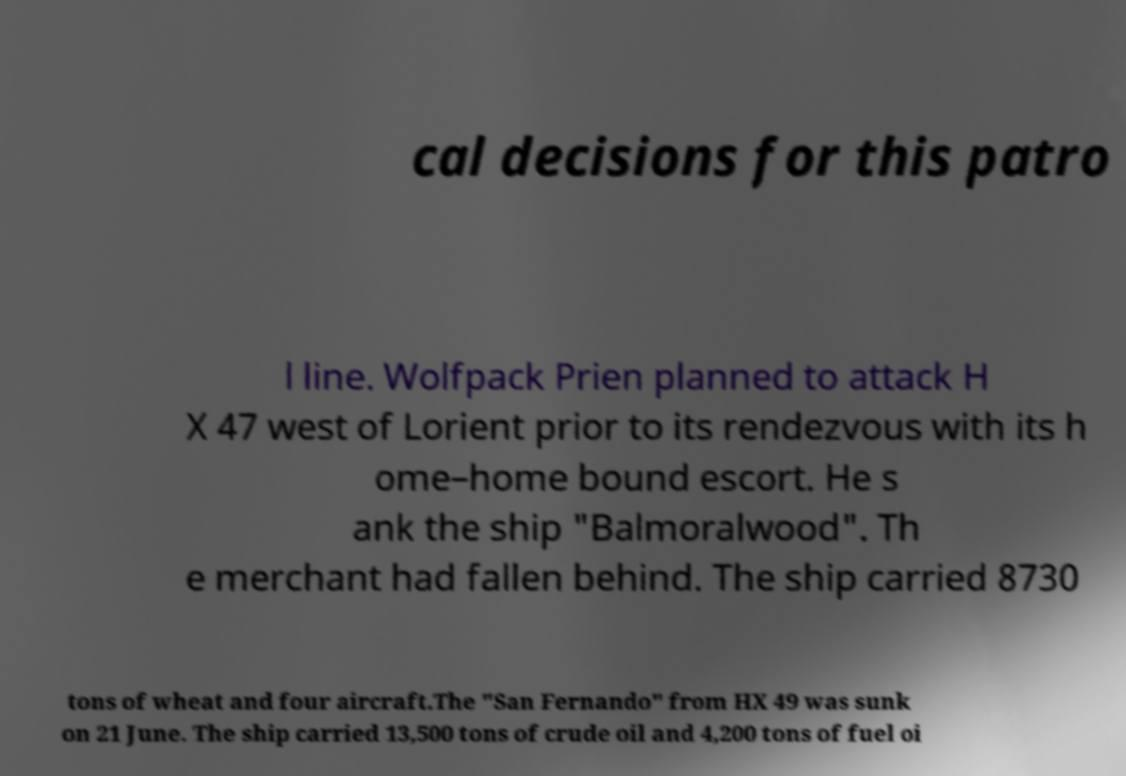Can you read and provide the text displayed in the image?This photo seems to have some interesting text. Can you extract and type it out for me? cal decisions for this patro l line. Wolfpack Prien planned to attack H X 47 west of Lorient prior to its rendezvous with its h ome–home bound escort. He s ank the ship "Balmoralwood". Th e merchant had fallen behind. The ship carried 8730 tons of wheat and four aircraft.The "San Fernando" from HX 49 was sunk on 21 June. The ship carried 13,500 tons of crude oil and 4,200 tons of fuel oi 